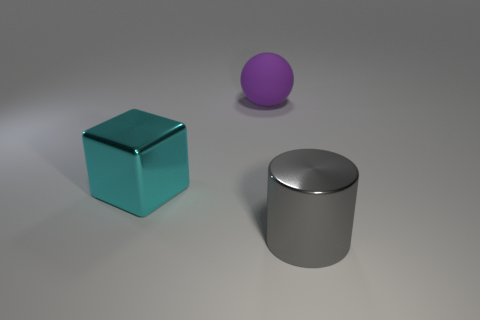There is a purple matte sphere that is to the right of the large object that is on the left side of the large object that is behind the cyan thing; what size is it?
Your answer should be very brief. Large. What is the color of the shiny cylinder?
Make the answer very short. Gray. Is the number of things that are behind the big cyan shiny object greater than the number of cyan shiny balls?
Your answer should be very brief. Yes. There is a big cyan metallic block; what number of cyan shiny objects are behind it?
Ensure brevity in your answer.  0. Are there any big cylinders in front of the metal thing that is on the left side of the large shiny cylinder that is on the right side of the big sphere?
Ensure brevity in your answer.  Yes. Does the cyan cube have the same size as the gray metal cylinder?
Make the answer very short. Yes. Are there an equal number of large cyan metallic blocks that are in front of the large sphere and objects that are in front of the large cube?
Make the answer very short. Yes. What is the shape of the shiny thing to the left of the big gray thing?
Your response must be concise. Cube. There is a cyan object that is the same size as the sphere; what is its shape?
Ensure brevity in your answer.  Cube. What is the color of the big metallic object on the left side of the rubber thing that is behind the thing that is left of the big purple rubber object?
Offer a very short reply. Cyan. 